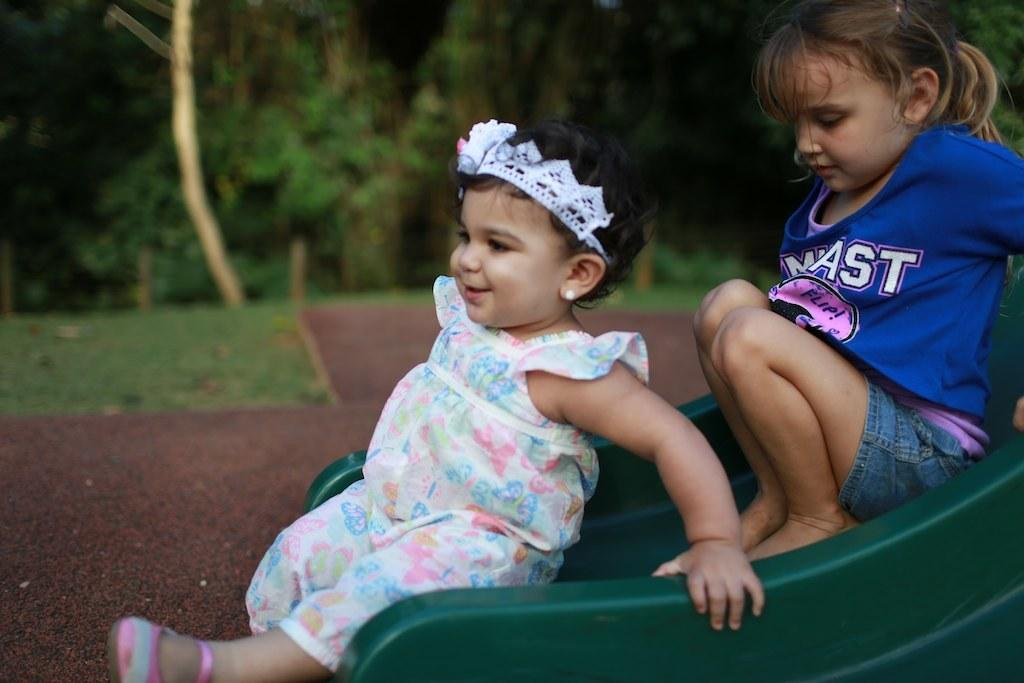How many people are in the image? There are two girls in the image. What activity are the girls engaged in? The girls are sliding on a green color sliding board. Can you describe the expression of one of the girls? One of the girls is smiling. What can be seen in the background of the image? There are trees in the background of the image. What type of design can be seen on the copper paper in the image? There is no copper paper present in the image. 